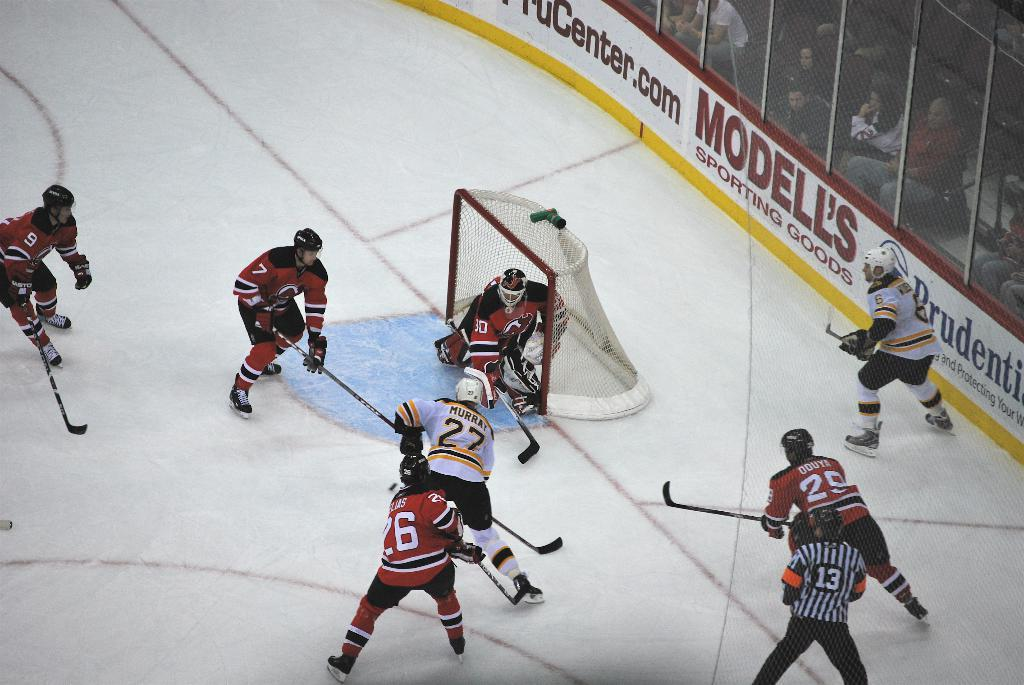<image>
Create a compact narrative representing the image presented. A hockey game is being played in a stadium which features an advertisement for Modell's Sporting Goods. 